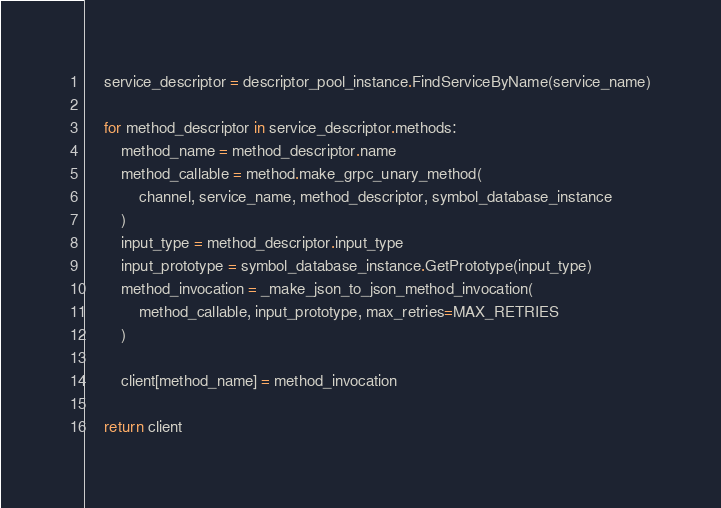Convert code to text. <code><loc_0><loc_0><loc_500><loc_500><_Python_>
    service_descriptor = descriptor_pool_instance.FindServiceByName(service_name)

    for method_descriptor in service_descriptor.methods:
        method_name = method_descriptor.name
        method_callable = method.make_grpc_unary_method(
            channel, service_name, method_descriptor, symbol_database_instance
        )
        input_type = method_descriptor.input_type
        input_prototype = symbol_database_instance.GetPrototype(input_type)
        method_invocation = _make_json_to_json_method_invocation(
            method_callable, input_prototype, max_retries=MAX_RETRIES
        )

        client[method_name] = method_invocation

    return client
</code> 